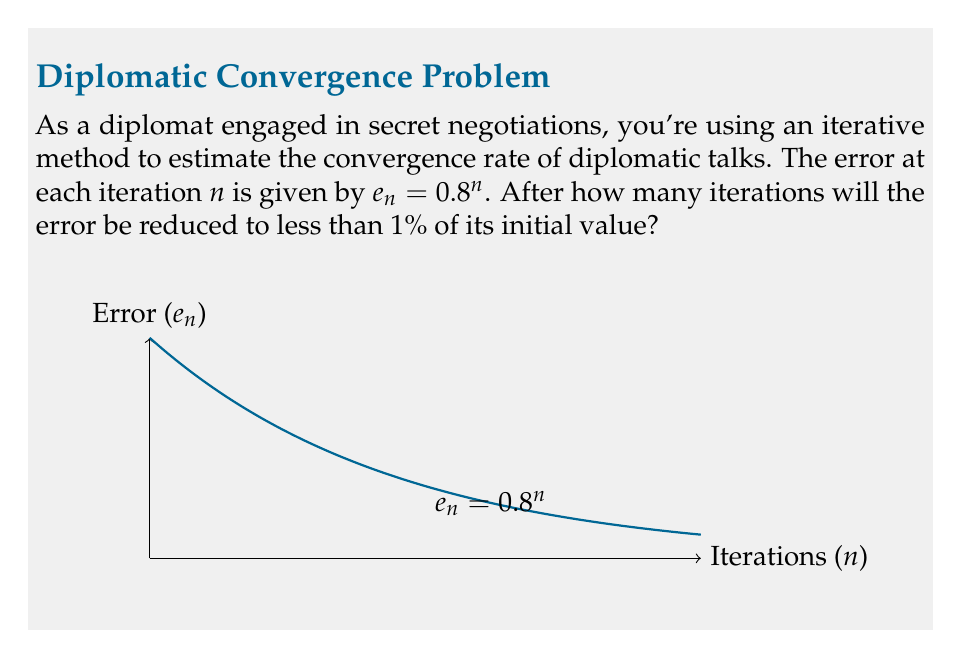Give your solution to this math problem. Let's approach this step-by-step:

1) We want to find $n$ such that $e_n < 0.01e_0$, where $e_0$ is the initial error.

2) We're given that $e_n = 0.8^n$. So we need to solve:

   $0.8^n < 0.01$

3) Taking logarithms of both sides:

   $n \log(0.8) < \log(0.01)$

4) Solving for $n$:

   $n > \frac{\log(0.01)}{\log(0.8)}$

5) Using a calculator or computer:

   $n > \frac{-2}{\log(0.8)} \approx 20.6$

6) Since $n$ must be an integer, we round up to the next whole number.

Therefore, after 21 iterations, the error will be less than 1% of its initial value.
Answer: 21 iterations 